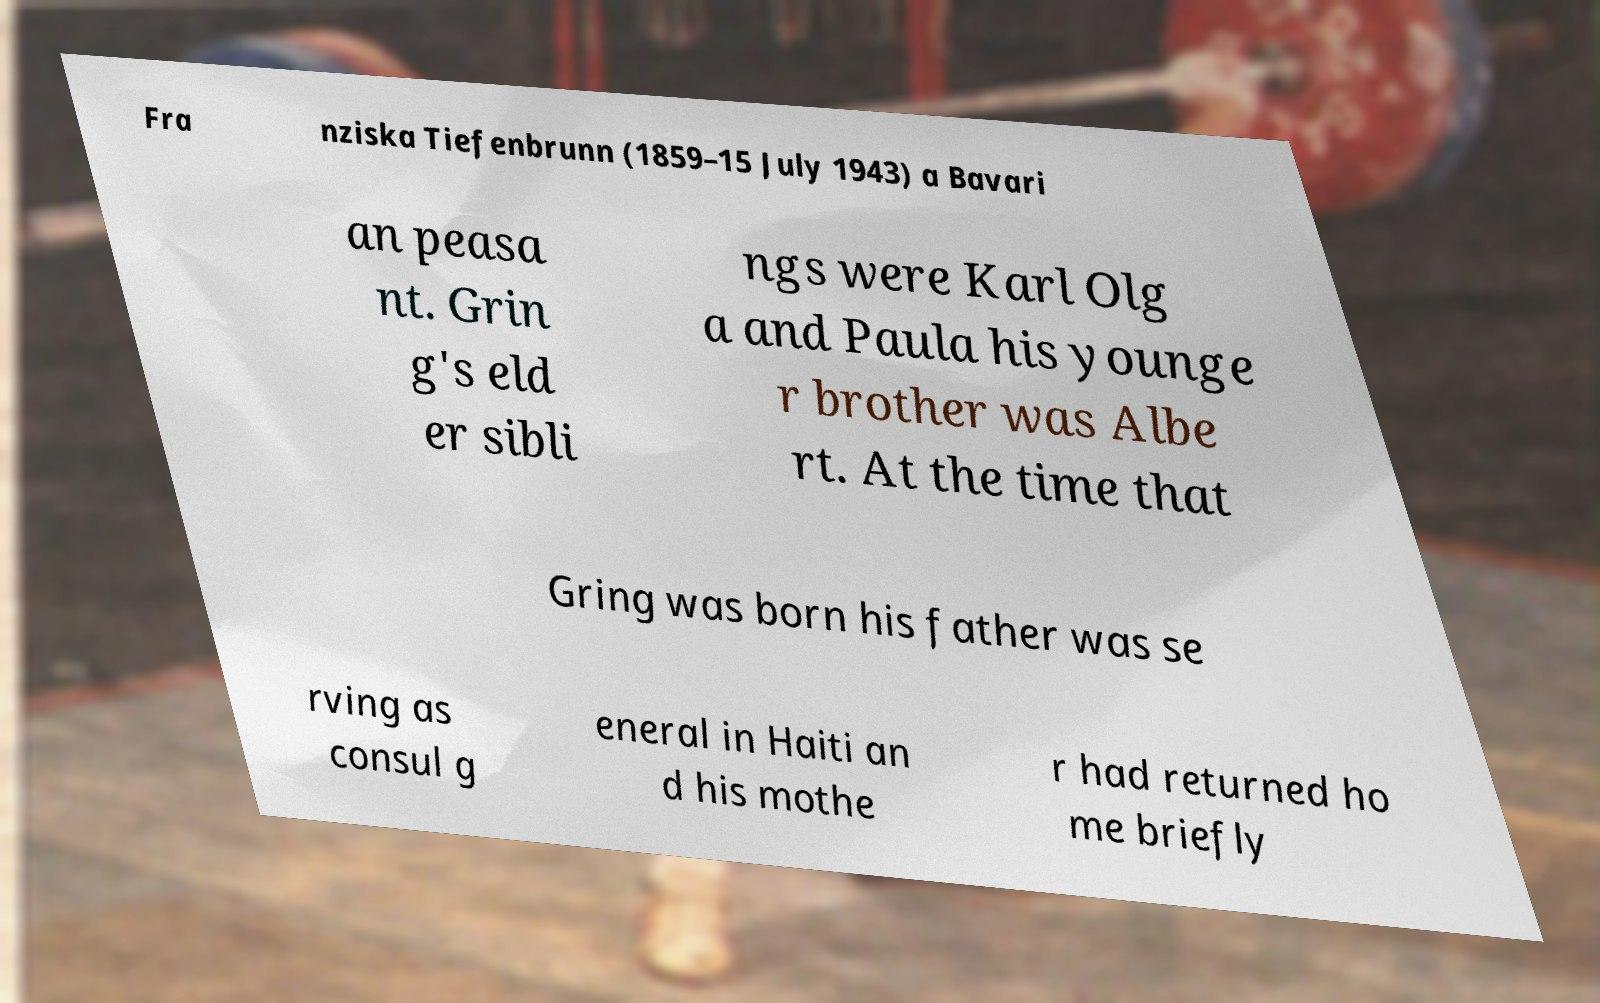For documentation purposes, I need the text within this image transcribed. Could you provide that? Fra nziska Tiefenbrunn (1859–15 July 1943) a Bavari an peasa nt. Grin g's eld er sibli ngs were Karl Olg a and Paula his younge r brother was Albe rt. At the time that Gring was born his father was se rving as consul g eneral in Haiti an d his mothe r had returned ho me briefly 